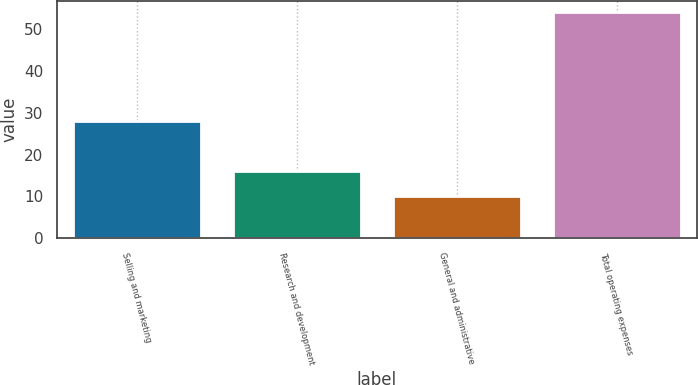<chart> <loc_0><loc_0><loc_500><loc_500><bar_chart><fcel>Selling and marketing<fcel>Research and development<fcel>General and administrative<fcel>Total operating expenses<nl><fcel>28<fcel>16<fcel>10<fcel>54<nl></chart> 